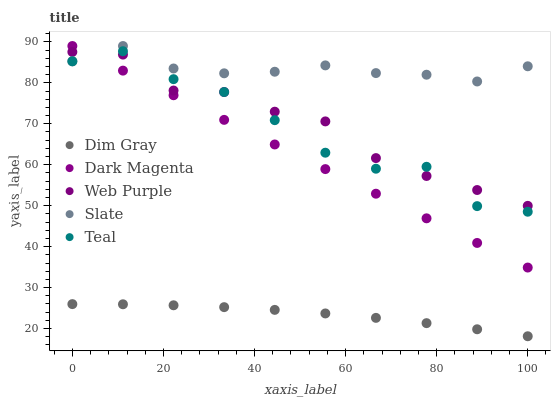Does Dim Gray have the minimum area under the curve?
Answer yes or no. Yes. Does Slate have the maximum area under the curve?
Answer yes or no. Yes. Does Web Purple have the minimum area under the curve?
Answer yes or no. No. Does Web Purple have the maximum area under the curve?
Answer yes or no. No. Is Dark Magenta the smoothest?
Answer yes or no. Yes. Is Teal the roughest?
Answer yes or no. Yes. Is Web Purple the smoothest?
Answer yes or no. No. Is Web Purple the roughest?
Answer yes or no. No. Does Dim Gray have the lowest value?
Answer yes or no. Yes. Does Web Purple have the lowest value?
Answer yes or no. No. Does Dark Magenta have the highest value?
Answer yes or no. Yes. Does Web Purple have the highest value?
Answer yes or no. No. Is Dim Gray less than Teal?
Answer yes or no. Yes. Is Web Purple greater than Dim Gray?
Answer yes or no. Yes. Does Teal intersect Web Purple?
Answer yes or no. Yes. Is Teal less than Web Purple?
Answer yes or no. No. Is Teal greater than Web Purple?
Answer yes or no. No. Does Dim Gray intersect Teal?
Answer yes or no. No. 